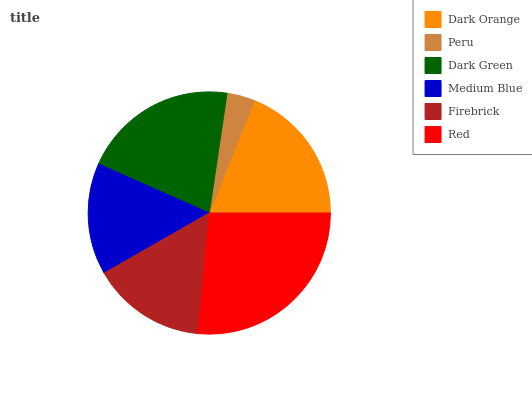Is Peru the minimum?
Answer yes or no. Yes. Is Red the maximum?
Answer yes or no. Yes. Is Dark Green the minimum?
Answer yes or no. No. Is Dark Green the maximum?
Answer yes or no. No. Is Dark Green greater than Peru?
Answer yes or no. Yes. Is Peru less than Dark Green?
Answer yes or no. Yes. Is Peru greater than Dark Green?
Answer yes or no. No. Is Dark Green less than Peru?
Answer yes or no. No. Is Dark Orange the high median?
Answer yes or no. Yes. Is Firebrick the low median?
Answer yes or no. Yes. Is Peru the high median?
Answer yes or no. No. Is Medium Blue the low median?
Answer yes or no. No. 